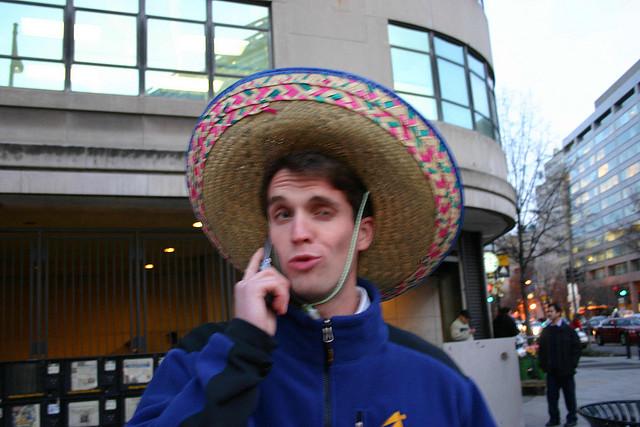In what country is this hat traditionally worn?
Short answer required. Mexico. What type of hat is the man wearing?
Keep it brief. Sombrero. Which hand holds a phone?
Give a very brief answer. Right. 